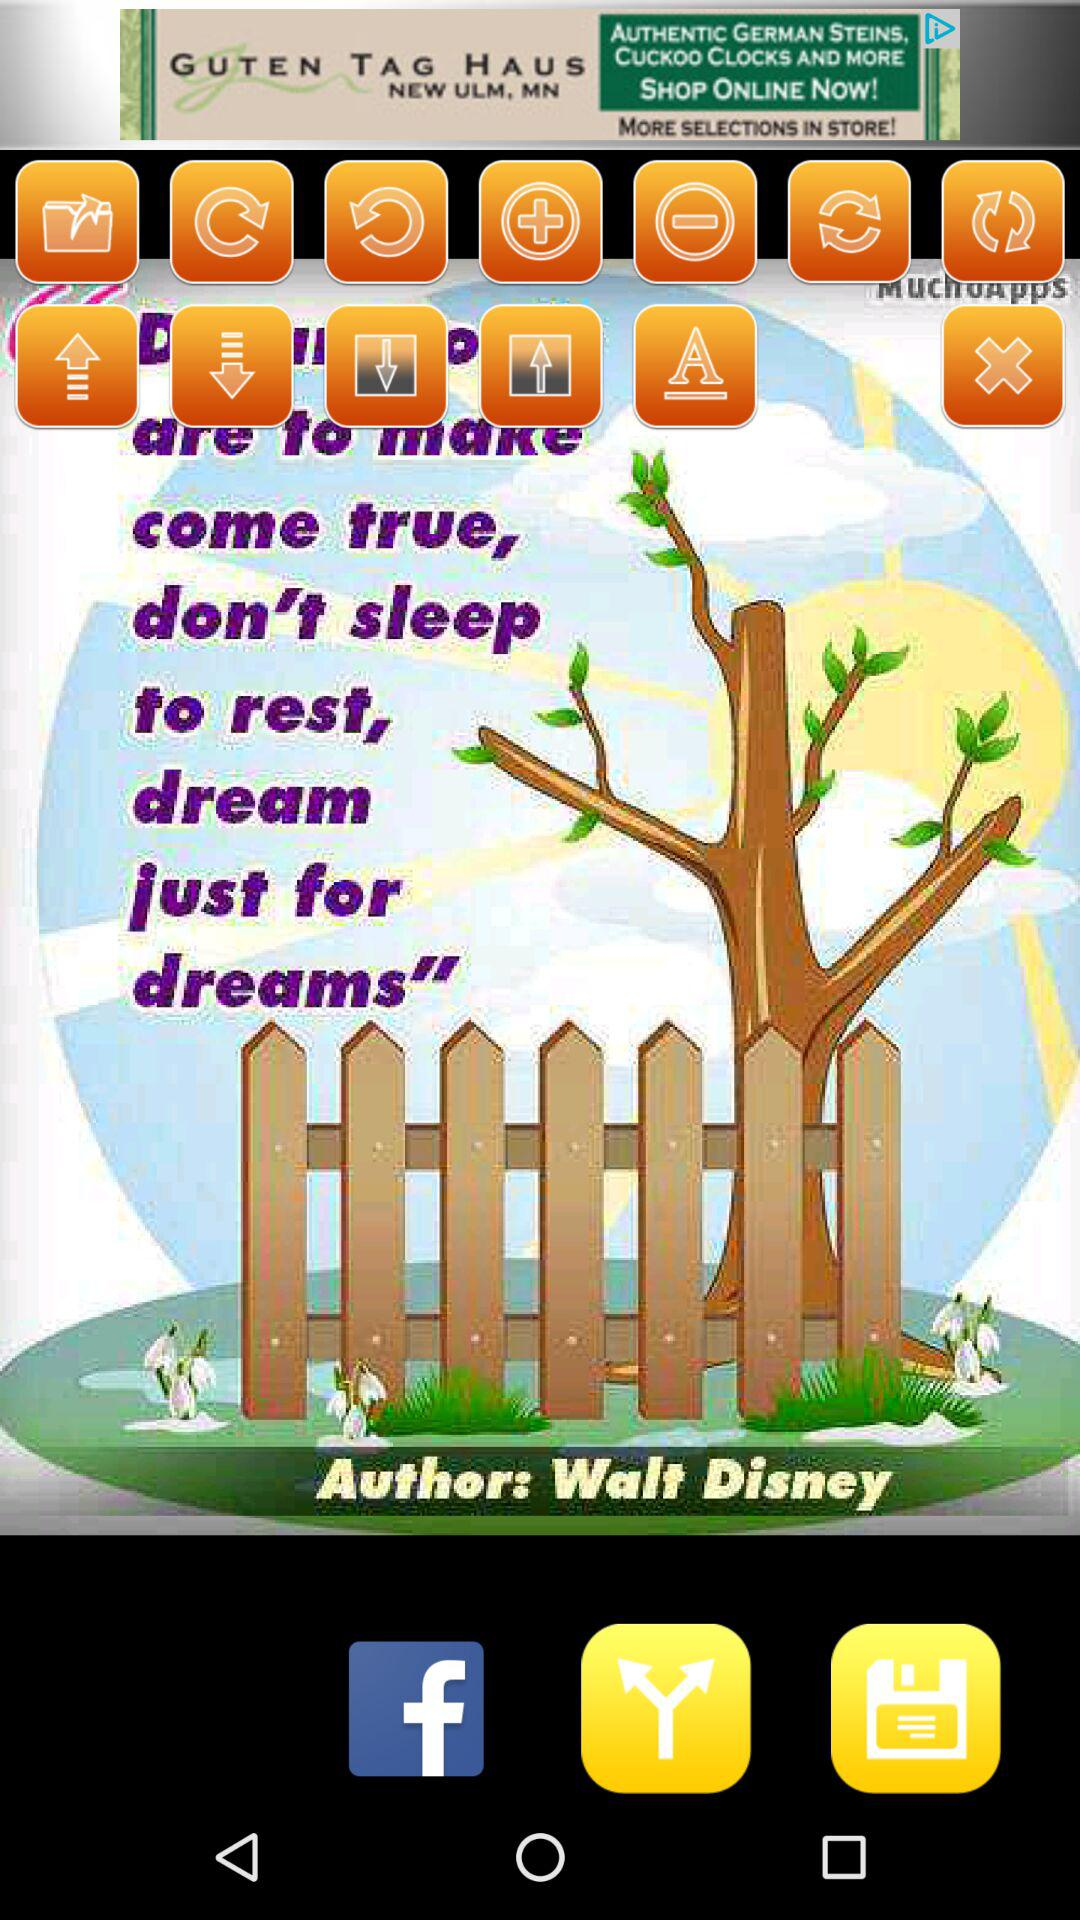What's the author name? The author name is Walt Disney. 